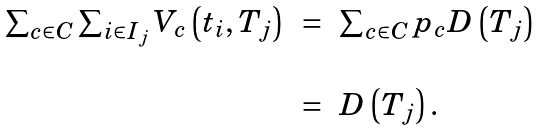<formula> <loc_0><loc_0><loc_500><loc_500>\begin{array} { r c l } \sum _ { c \in C } \sum _ { i \in I _ { j } } V _ { c } \left ( t _ { i } , T _ { j } \right ) & = & \sum _ { c \in C } p _ { c } D \left ( T _ { j } \right ) \\ \\ & = & D \left ( T _ { j } \right ) . \end{array}</formula> 